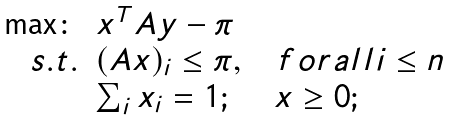<formula> <loc_0><loc_0><loc_500><loc_500>\begin{array} { r l } \max \colon & x ^ { T } A y - \pi \\ s . t . & ( A x ) _ { i } \leq \pi , \quad f o r a l l i \leq n \\ & \sum _ { i } x _ { i } = 1 ; \quad \ x \geq 0 ; \end{array}</formula> 